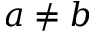<formula> <loc_0><loc_0><loc_500><loc_500>a \neq b</formula> 